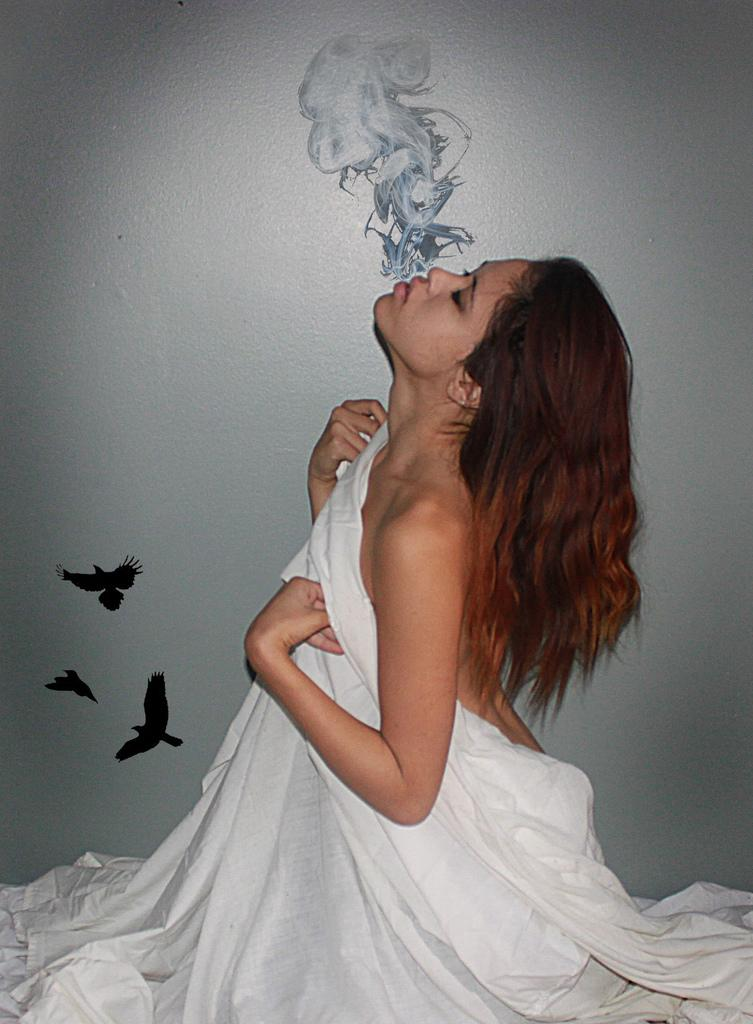Who is present in the image? There is a woman in the image. What is the woman holding in the image? The woman is holding a white cloth. What direction is the woman looking in the image? The woman is looking upwards. What can be seen on the wall in the image? There is a wall painting on the wall. What is depicted in the wall painting? The wall painting depicts fumes and birds. What type of pan is being used by the woman in the image? There is no pan present in the image; the woman is holding a white cloth. What is the woman doing with her neck in the image? The woman's neck is not performing any action in the image; she is simply looking upwards. 